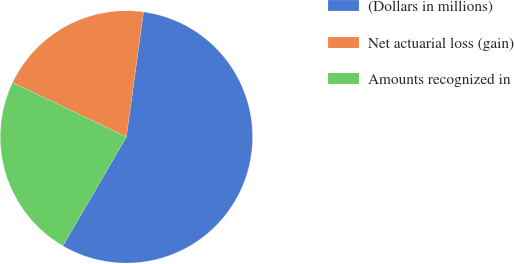Convert chart. <chart><loc_0><loc_0><loc_500><loc_500><pie_chart><fcel>(Dollars in millions)<fcel>Net actuarial loss (gain)<fcel>Amounts recognized in<nl><fcel>56.24%<fcel>20.07%<fcel>23.69%<nl></chart> 